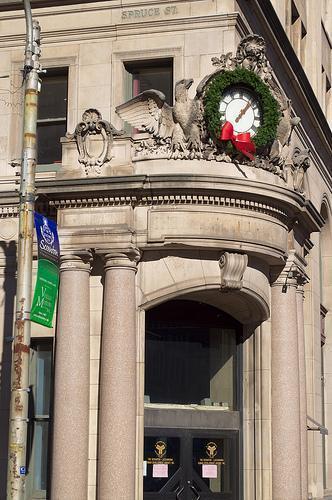How many columns are directly to the right of the pole?
Give a very brief answer. 2. 